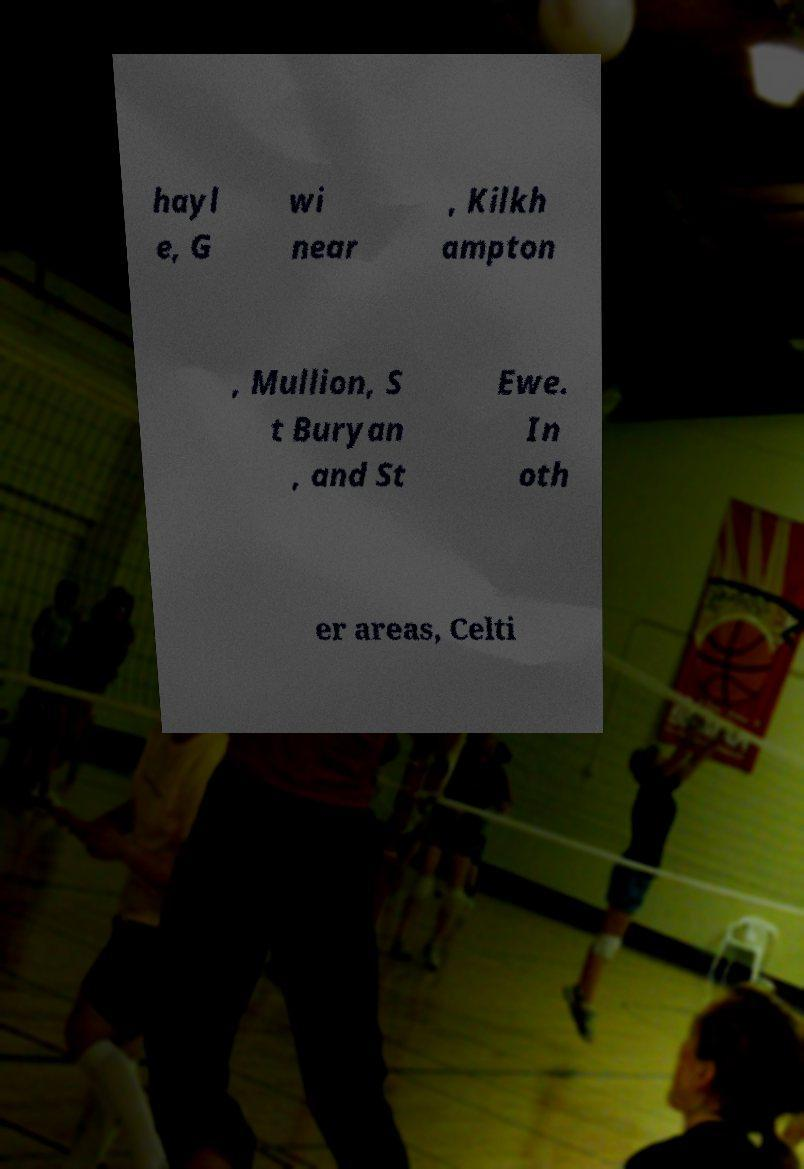I need the written content from this picture converted into text. Can you do that? hayl e, G wi near , Kilkh ampton , Mullion, S t Buryan , and St Ewe. In oth er areas, Celti 